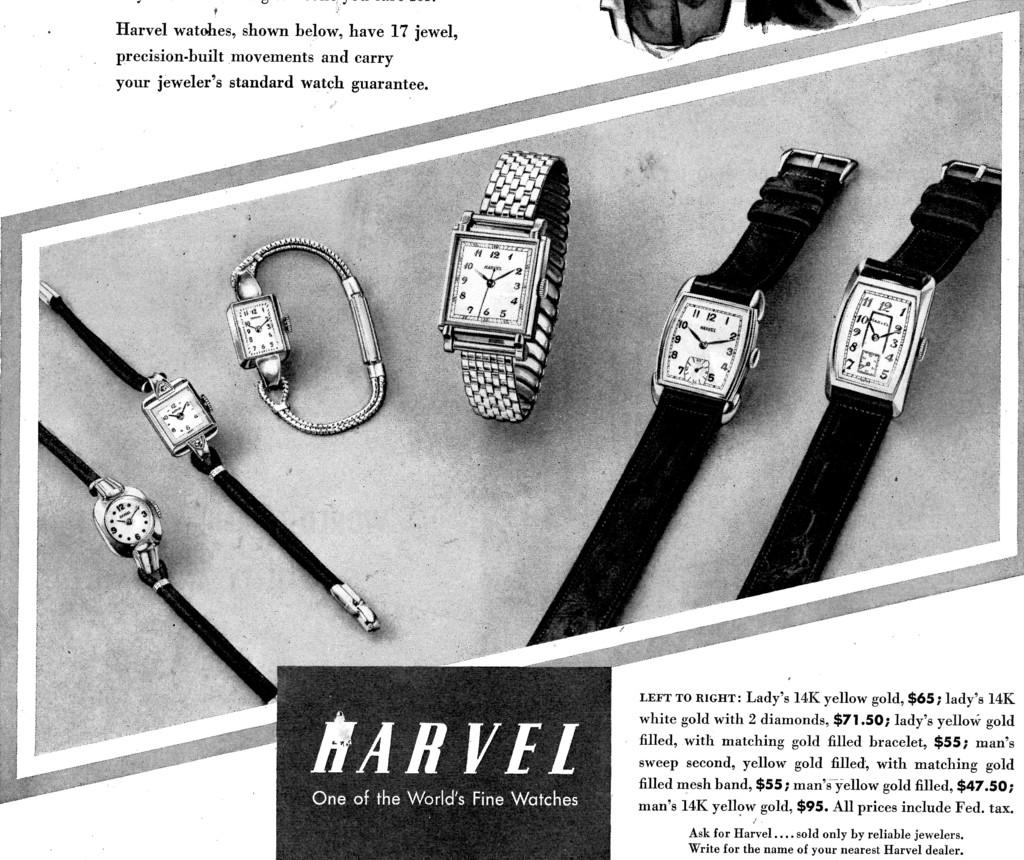<image>
Render a clear and concise summary of the photo. a ad for watches called Harvel listed and priced. 